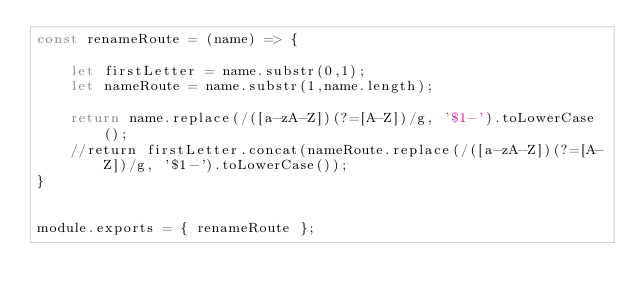Convert code to text. <code><loc_0><loc_0><loc_500><loc_500><_JavaScript_>const renameRoute = (name) => {
    
    let firstLetter = name.substr(0,1);
    let nameRoute = name.substr(1,name.length);
    
    return name.replace(/([a-zA-Z])(?=[A-Z])/g, '$1-').toLowerCase();
    //return firstLetter.concat(nameRoute.replace(/([a-zA-Z])(?=[A-Z])/g, '$1-').toLowerCase());
}


module.exports = { renameRoute };</code> 